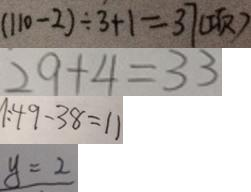Convert formula to latex. <formula><loc_0><loc_0><loc_500><loc_500>( 1 1 0 - 2 ) \div 3 + 1 = 3 7 ( 项 ) 
 2 9 + 4 = 3 3 
 1 : 4 9 - 3 8 = 1 1 
 y = 2</formula> 